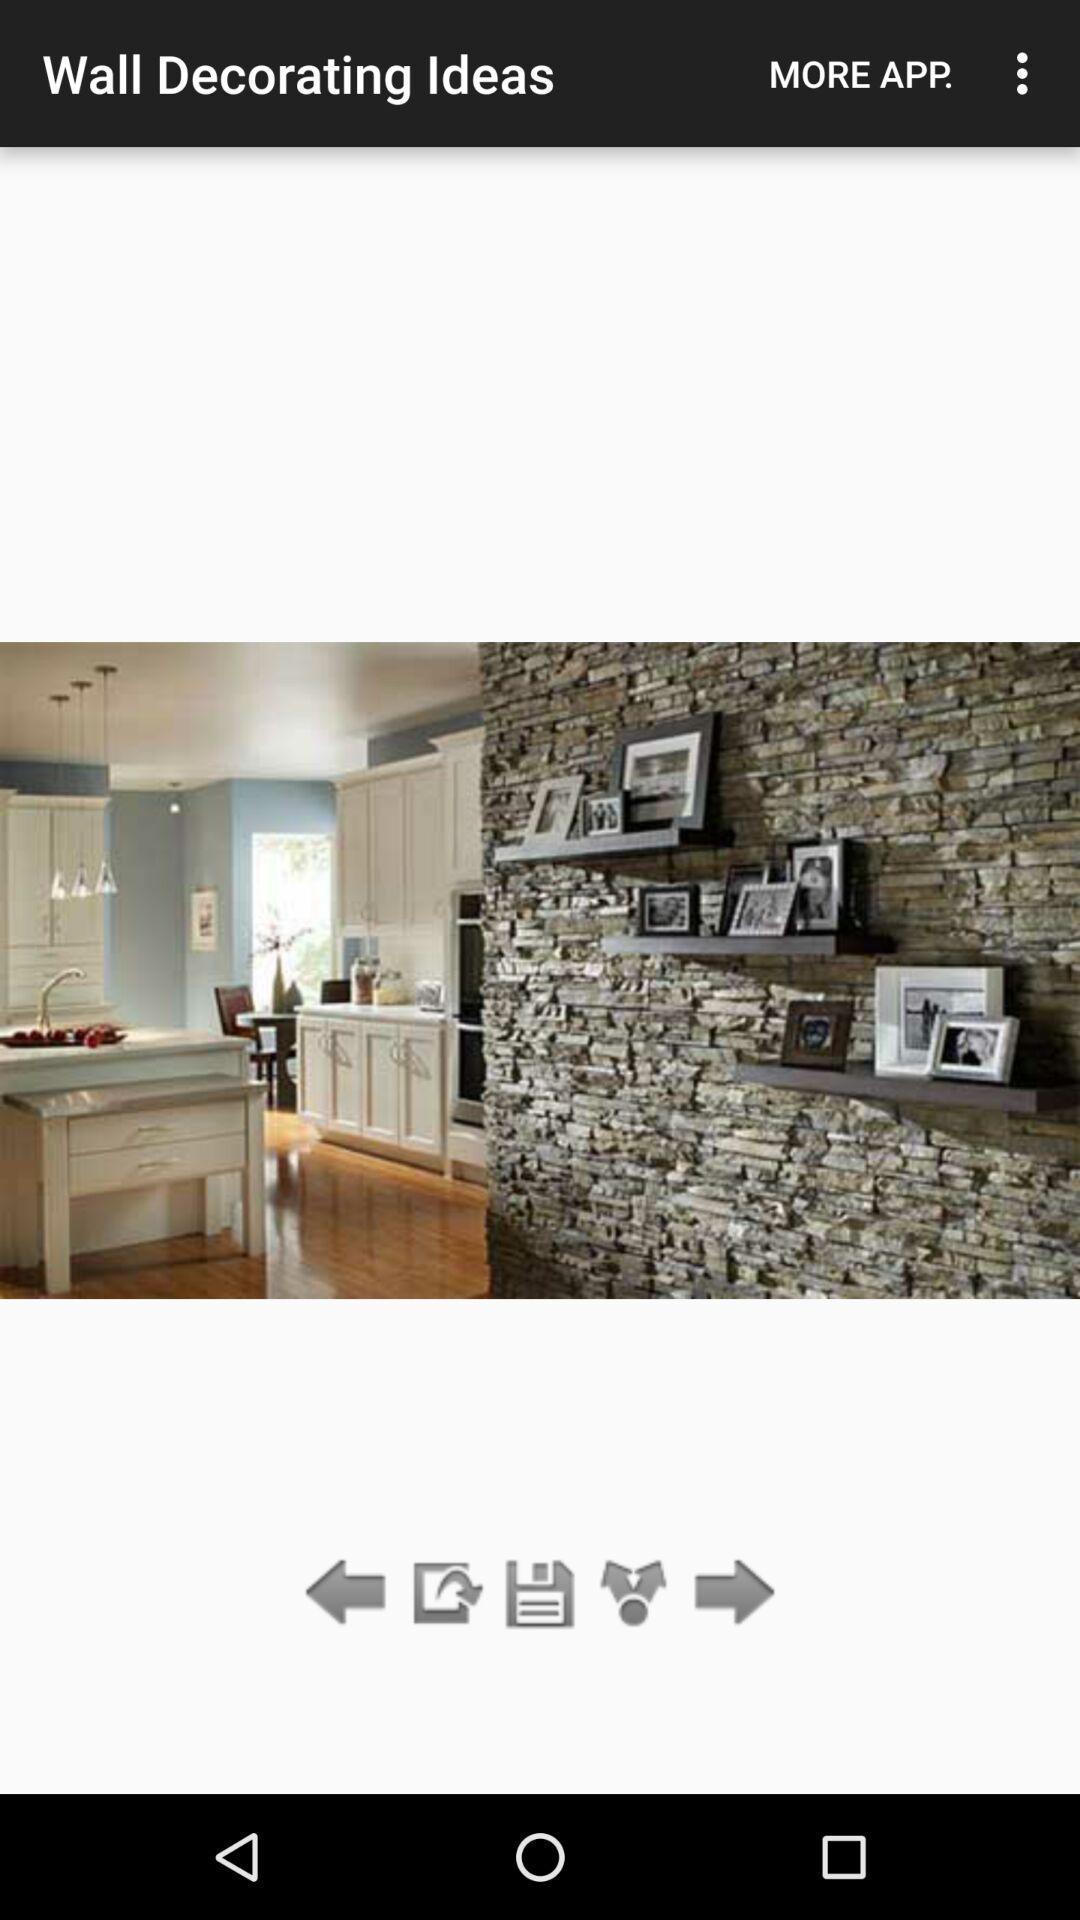Summarize the main components in this picture. Screen showing a picture of wall layout on an app. 